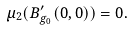<formula> <loc_0><loc_0><loc_500><loc_500>\mu _ { 2 } ( B ^ { \prime } _ { g _ { 0 } } ( 0 , 0 ) ) = 0 .</formula> 